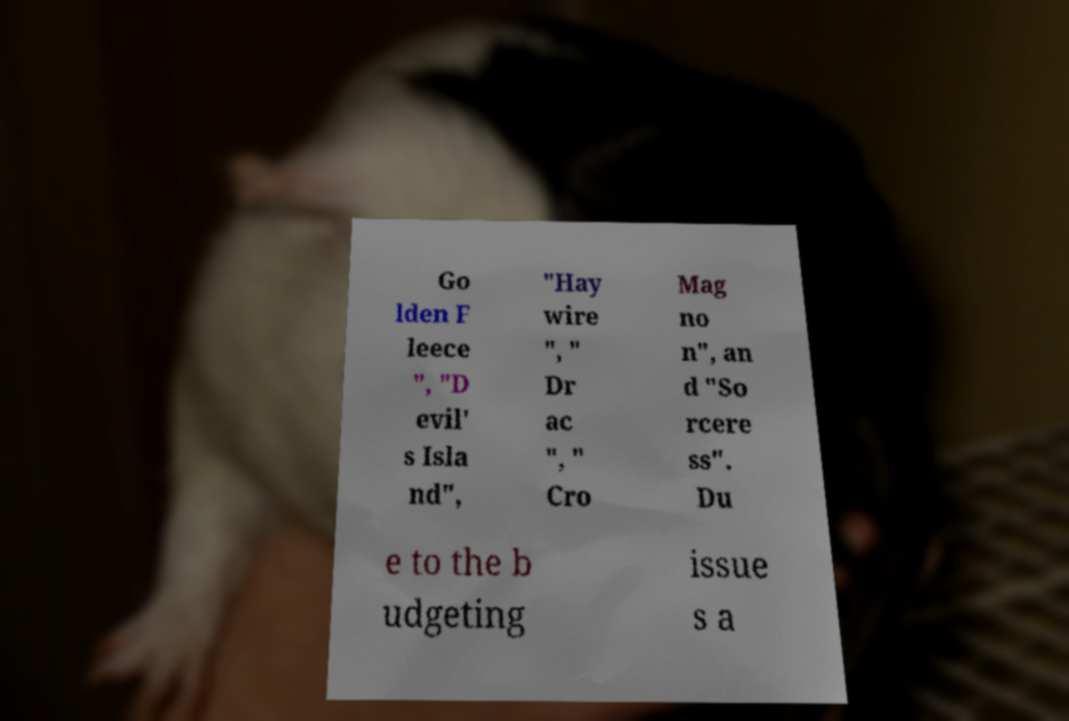There's text embedded in this image that I need extracted. Can you transcribe it verbatim? Go lden F leece ", "D evil' s Isla nd", "Hay wire ", " Dr ac ", " Cro Mag no n", an d "So rcere ss". Du e to the b udgeting issue s a 